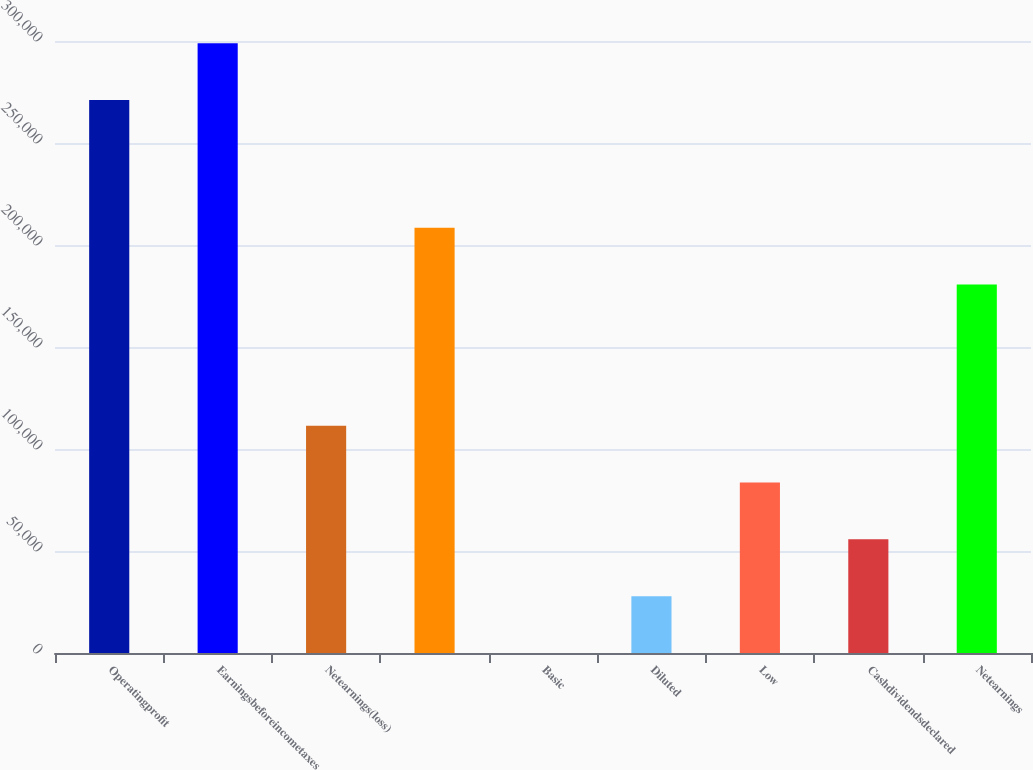<chart> <loc_0><loc_0><loc_500><loc_500><bar_chart><fcel>Operatingprofit<fcel>Earningsbeforeincometaxes<fcel>Netearnings(loss)<fcel>Unnamed: 3<fcel>Basic<fcel>Diluted<fcel>Low<fcel>Cashdividendsdeclared<fcel>Netearnings<nl><fcel>271088<fcel>298947<fcel>111434<fcel>208458<fcel>0.04<fcel>27858.6<fcel>83575.8<fcel>55717.2<fcel>180599<nl></chart> 